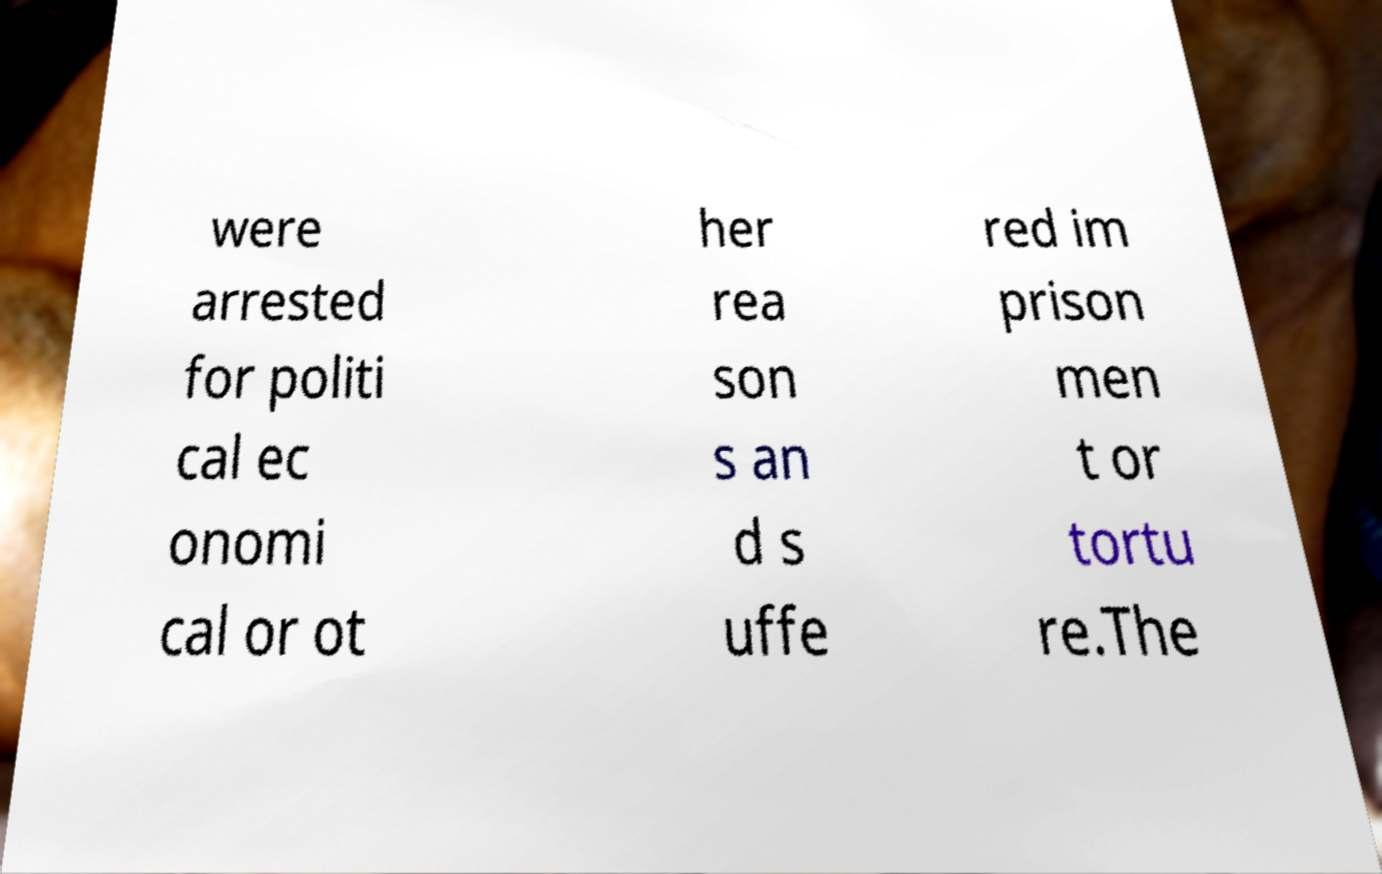There's text embedded in this image that I need extracted. Can you transcribe it verbatim? were arrested for politi cal ec onomi cal or ot her rea son s an d s uffe red im prison men t or tortu re.The 